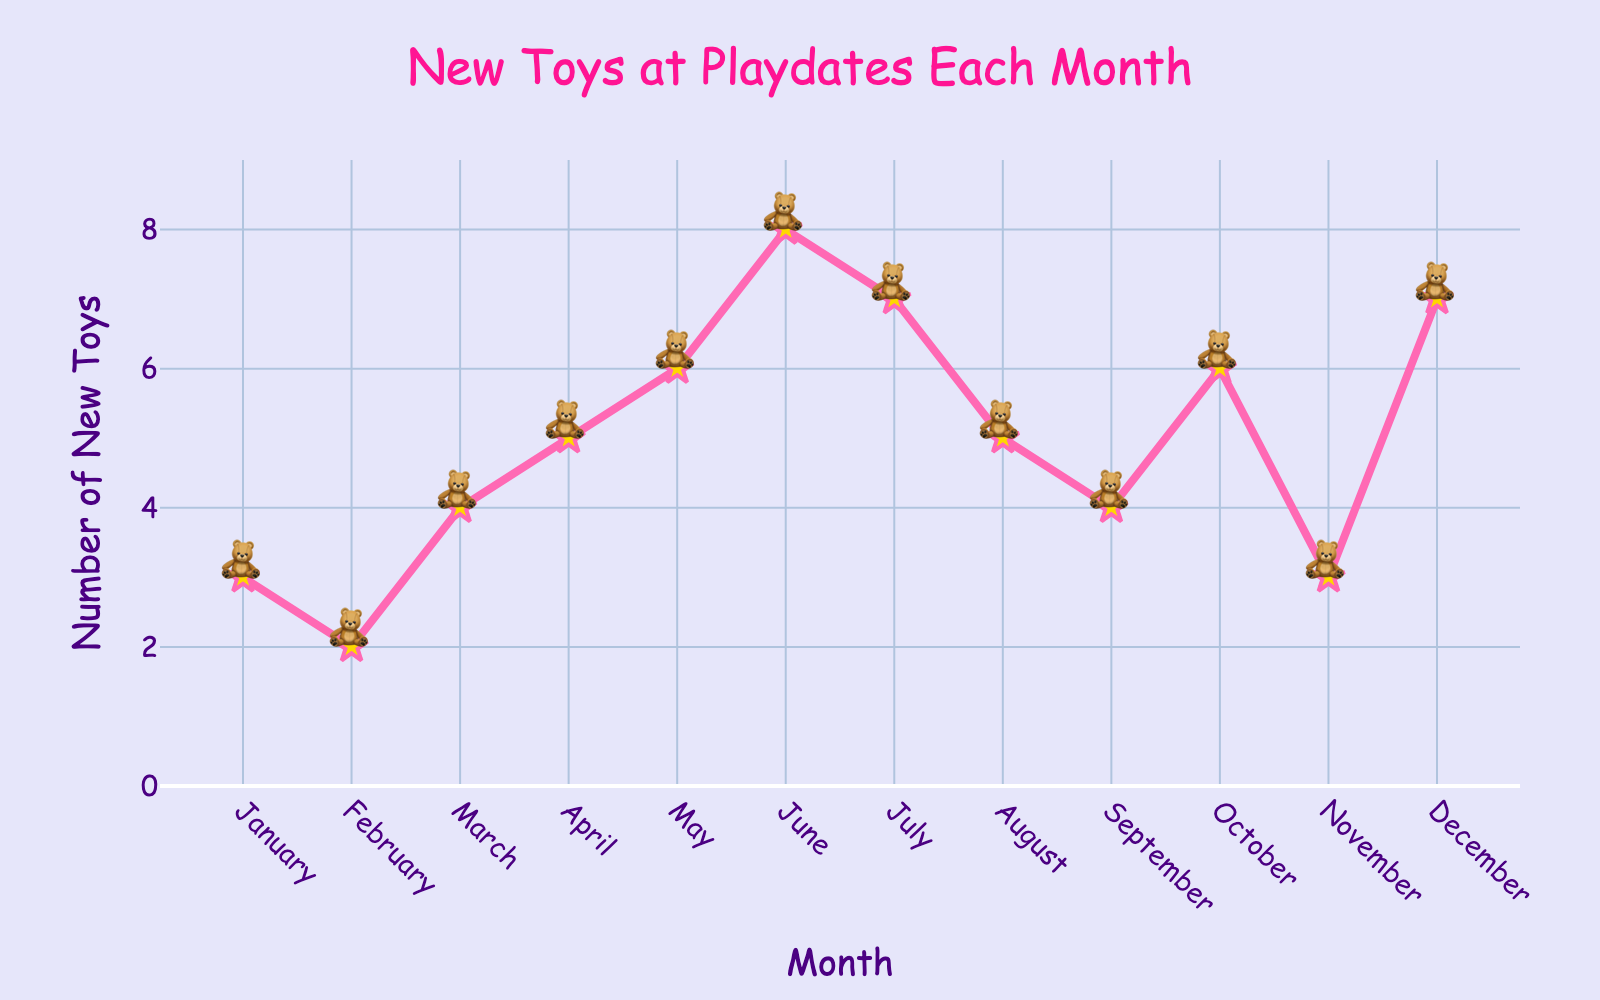What is the total number of new toys introduced from January to March? First, note the number of new toys for each month: January (3), February (2), March (4). Add them together: 3 + 2 + 4 = 9
Answer: 9 In which month were the fewest new toys introduced? By looking at each data point, we find that February had the fewest new toys with only 2 new toys introduced.
Answer: February Which month had more new toys, April or July? April had 5 new toys and July had 7 new toys. Comparing these values, we see that July had more new toys than April.
Answer: July What is the average number of new toys introduced per month? To find the average, sum all the new toys introduced : 3 + 2 + 4 + 5 + 6 + 8 + 7 + 5 + 4 + 6 + 3 + 7 = 60. Divide by the number of months (12): 60 / 12 = 5.
Answer: 5 How many new toys were introduced in the second half of the year (July to December)? Note the new toys for July to December: July (7), August (5), September (4), October (6), November (3), December (7). Add them together: 7 + 5 + 4 + 6 + 3 + 7 = 32
Answer: 32 Compare the total number of new toys introduced in the first half (January to June) and the second half (July to December) of the year. Which half had more new toys introduced? Calculate the total for January to June: 3 + 2 + 4 + 5 + 6 + 8 = 28. Calculate the total for July to December: 7 + 5 + 4 + 6 + 3 + 7 = 32. Compare the totals: 32 is greater than 28, so the second half had more new toys introduced.
Answer: Second half What is the difference in the number of new toys introduced between the month with the most toys and the month with the fewest toys? The month with the most toys is June (8), and the month with the fewest toys is February (2). The difference: 8 - 2 = 6
Answer: 6 Which month showed the highest increase in new toys introduced compared to the previous month? Calculate the month-over-month increases: Jan-Feb (2-3=-1), Feb-Mar (4-2=2), Mar-Apr (5-4=1), Apr-May (6-5=1), May-Jun (8-6=2), Jun-Jul (7-8=-1), Jul-Aug (5-7=-2), Aug-Sep (4-5=-1), Sep-Oct (6-4=2), Oct-Nov (3-6=-3), Nov-Dec (7-3=4). The highest increase is November to December with a difference of 4.
Answer: December 